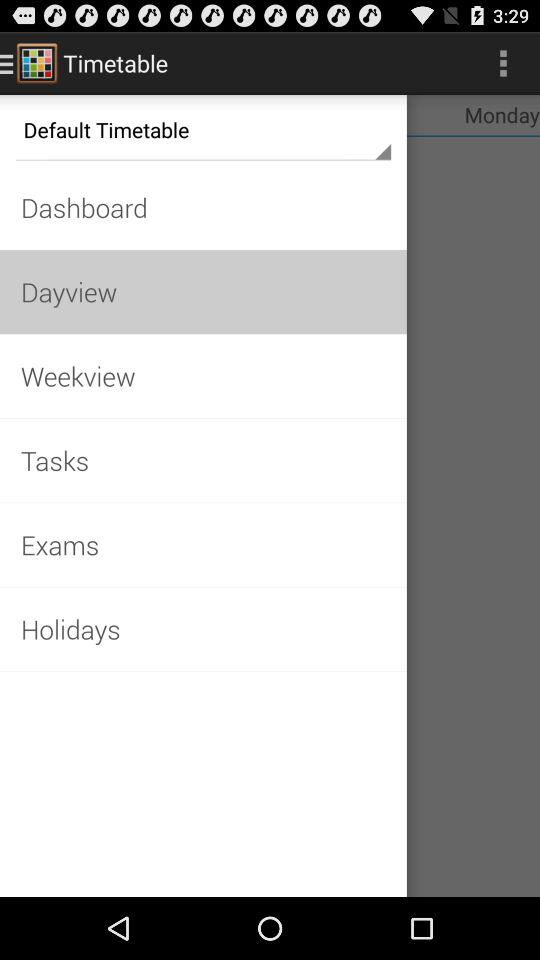What is the application name? The application name is "Timetable". 